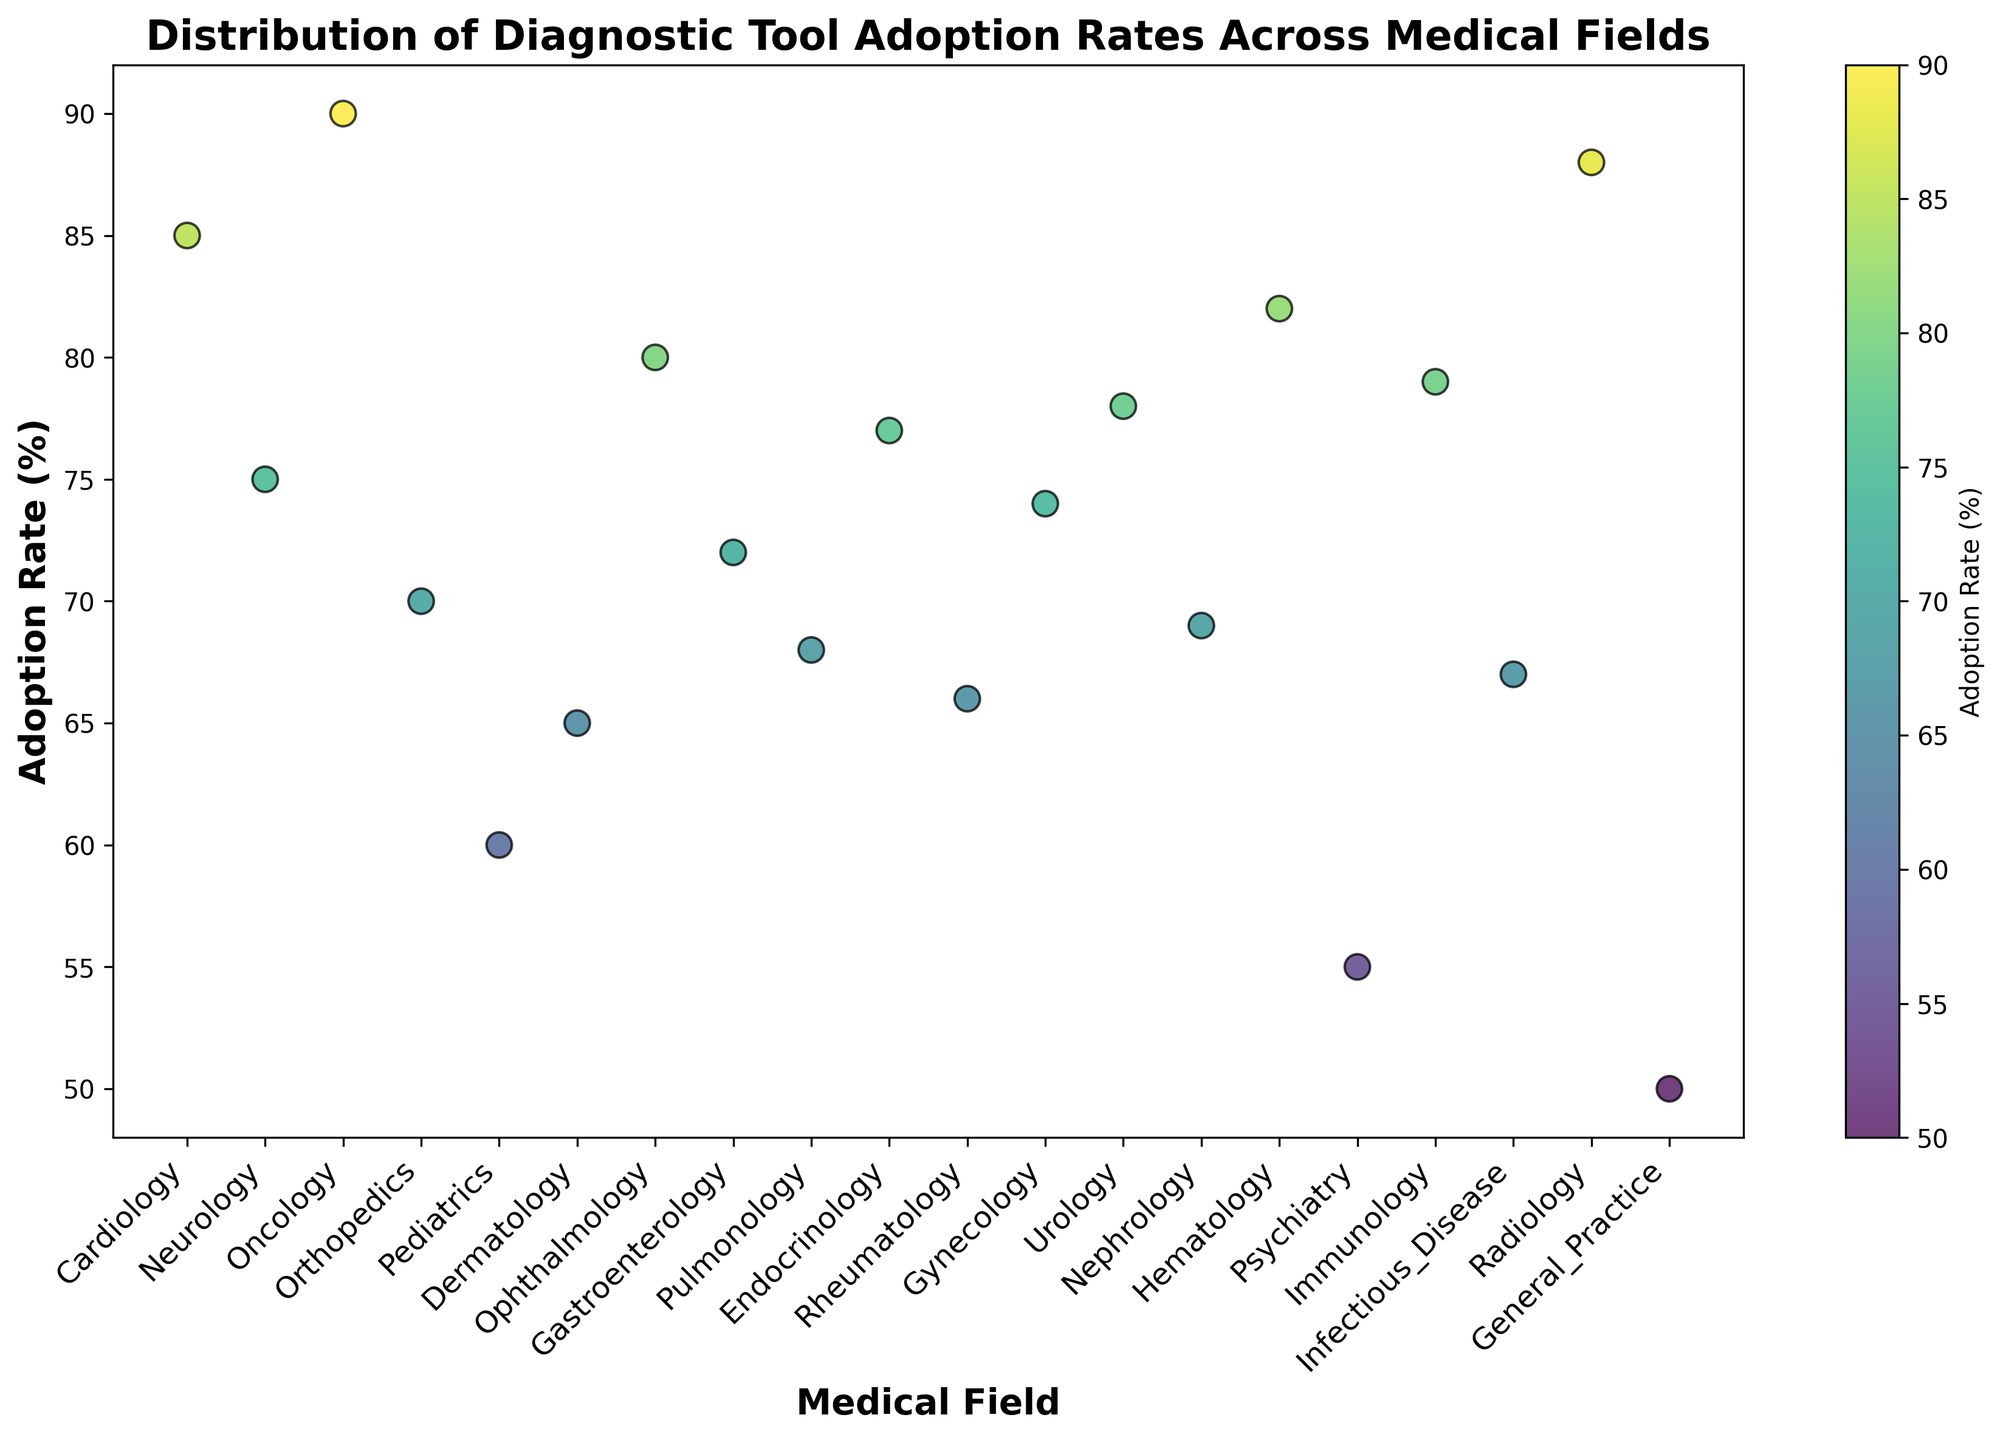What's the medical field with the highest adoption rate of diagnostic tools? Look at the scatter plot and identify the field with the highest y-value representing the adoption rate. The highest adoption rate is 90% in the Oncology field.
Answer: Oncology What's the adoption rate difference between Neurology and Psychiatry? Find and subtract the adoption rate of Psychiatry (55%) from that of Neurology (75%) on the scatter plot. The difference is 75% - 55% = 20%.
Answer: 20% Which medical fields have adoption rates greater than 80%? Identify the fields where the y-values (adoption rates) are above 80% on the scatter plot. These fields are Cardiology (85%), Oncology (90%), Ophthalmology (80%), Radiology (88%), and Hematology (82%).
Answer: Cardiology, Oncology, Ophthalmology, Radiology, Hematology What’s the average adoption rate among the fields with the lowest and highest adoption rates? Identify the fields with the lowest (General Practice, 50%) and highest (Oncology, 90%) adoption rates on the scatter plot. Calculate the average by summing the two rates and dividing by 2: (50% + 90%) / 2 = 70%.
Answer: 70% How many fields have adoption rates between 65% and 75%? Count the number of points on the scatter plot with y-values (adoption rates) between 65% and 75%. The relevant fields are Neurology (75%), Orthopedics (70%), Gastroenterology (72%), Dermatology (65%), Gynecology (74%), Nephrology (69%), Rheumatology (66%), Pulmonology (68%), and Infectious Disease (67%), making a total of 9.
Answer: 9 Which field has a higher adoption rate: Gastroenterology or Endocrinology? Look at the scatter plot and compare the adoption rates of Gastroenterology (72%) and Endocrinology (77%). Endocrinology has a higher adoption rate.
Answer: Endocrinology What is the color range of the adoption rates on the scatter plot? Observe the colors depicted in the color bar associated with different adoption rates. The color bar ranges from darker to brighter shades of the 'viridis' color map as the adoption rate increases. The range includes shades from dark purple to bright yellow-green.
Answer: Dark purple to bright yellow-green Identify the medical field with an adoption rate of 60%. Find the point on the scatter plot corresponding to the adoption rate of 60%. The field with this adoption rate is Pediatrics.
Answer: Pediatrics How does the adoption rate in Immunology compare with that of Pulmonology? Refer to the scatter plot to see the adoption rates: Immunology has 79%, and Pulmonology has 68%. Immunology has a higher adoption rate than Pulmonology.
Answer: Immunology has a higher rate If you were to categorize fields with adoption rates above the median, which fields would be included? Arrange all adoption rates in ascending order to find the median. Since there are 20 fields, the median is the average of the 10th and 11th rates, which are between 70% (Orthopedics) and 72% (Gastroenterology). Fields above this range include Cardiology, Neurology, Oncology, Ophthalmology, Endocrinology, Gynecology, Urology, Hematology, Immunology, and Radiology.
Answer: Cardiology, Neurology, Oncology, Ophthalmology, Endocrinology, Gynecology, Urology, Hematology, Immunology, Radiology 